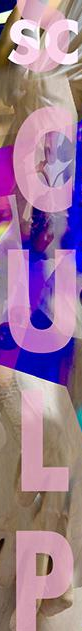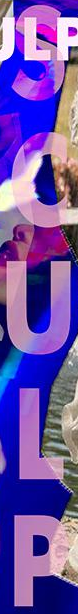What text appears in these images from left to right, separated by a semicolon? SCULP; SCULP 